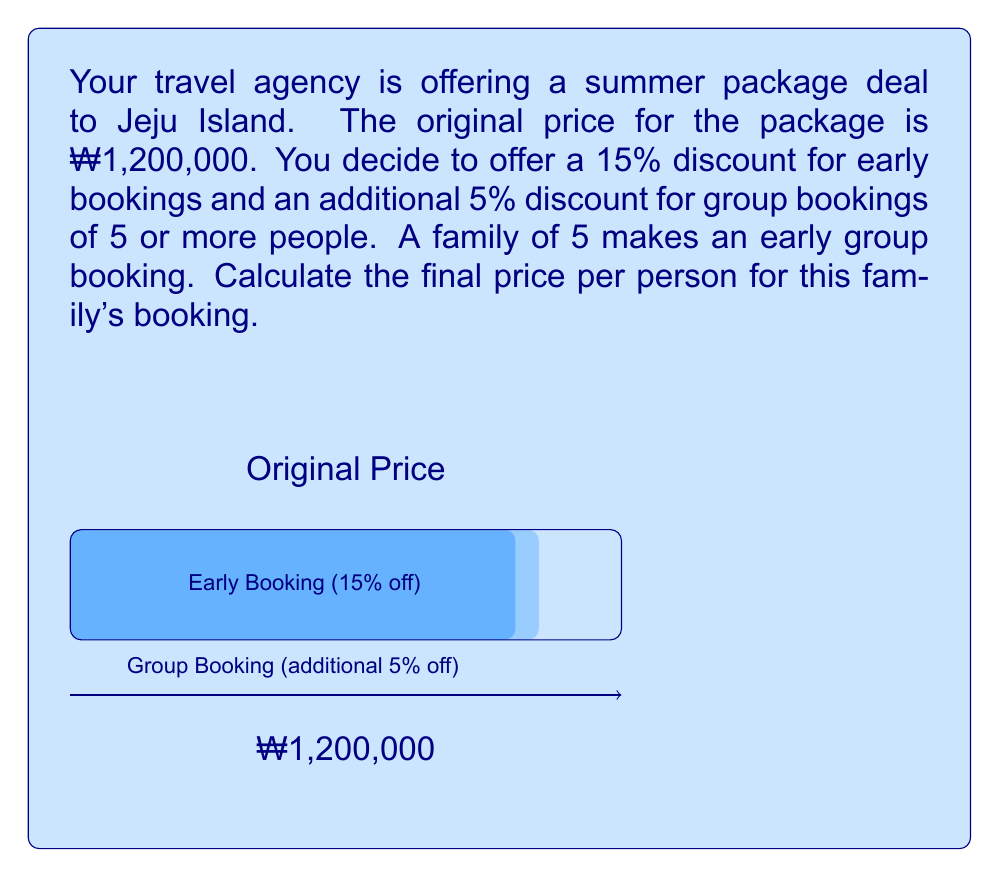Provide a solution to this math problem. Let's break this down step-by-step:

1) First, calculate the price after the early booking discount:
   $$\text{Early booking price} = \text{Original price} \times (1 - 0.15)$$
   $$= ₩1,200,000 \times 0.85 = ₩1,020,000$$

2) Now, apply the additional group booking discount to this new price:
   $$\text{Final group price} = \text{Early booking price} \times (1 - 0.05)$$
   $$= ₩1,020,000 \times 0.95 = ₩969,000$$

3) This ₩969,000 is the total price for the family of 5. To get the price per person, divide by 5:
   $$\text{Price per person} = \frac{\text{Final group price}}{5}$$
   $$= \frac{₩969,000}{5} = ₩193,800$$

Therefore, each person in the family will pay ₩193,800 for the package deal.

Note: The total discount percentage is not simply 15% + 5% = 20%. The discounts are applied sequentially, resulting in a slightly larger total discount:
$$1 - (0.85 \times 0.95) = 0.1925 \text{ or } 19.25\%$$
Answer: ₩193,800 per person 